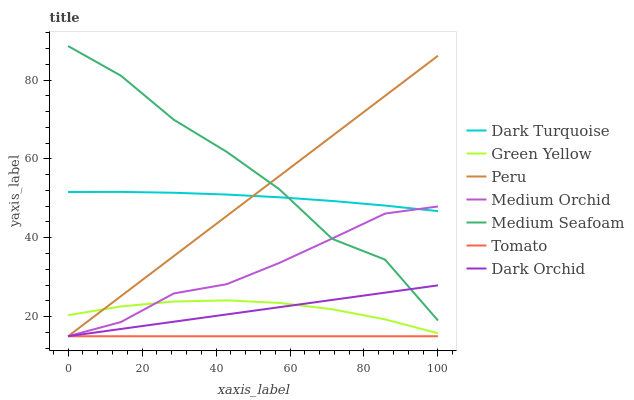Does Tomato have the minimum area under the curve?
Answer yes or no. Yes. Does Medium Seafoam have the maximum area under the curve?
Answer yes or no. Yes. Does Dark Turquoise have the minimum area under the curve?
Answer yes or no. No. Does Dark Turquoise have the maximum area under the curve?
Answer yes or no. No. Is Tomato the smoothest?
Answer yes or no. Yes. Is Medium Seafoam the roughest?
Answer yes or no. Yes. Is Dark Turquoise the smoothest?
Answer yes or no. No. Is Dark Turquoise the roughest?
Answer yes or no. No. Does Tomato have the lowest value?
Answer yes or no. Yes. Does Dark Turquoise have the lowest value?
Answer yes or no. No. Does Medium Seafoam have the highest value?
Answer yes or no. Yes. Does Dark Turquoise have the highest value?
Answer yes or no. No. Is Tomato less than Green Yellow?
Answer yes or no. Yes. Is Dark Turquoise greater than Tomato?
Answer yes or no. Yes. Does Dark Orchid intersect Medium Orchid?
Answer yes or no. Yes. Is Dark Orchid less than Medium Orchid?
Answer yes or no. No. Is Dark Orchid greater than Medium Orchid?
Answer yes or no. No. Does Tomato intersect Green Yellow?
Answer yes or no. No. 